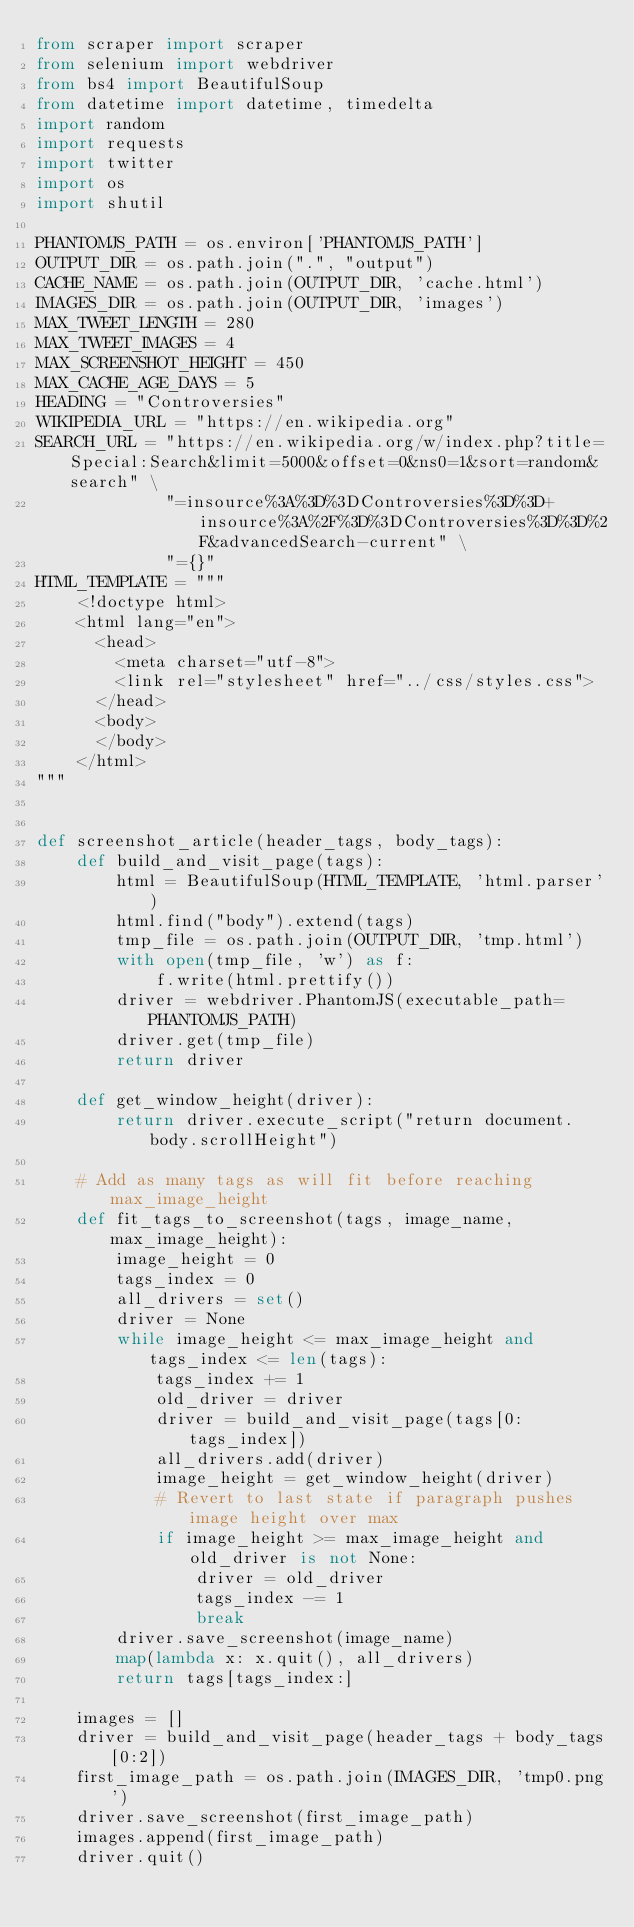Convert code to text. <code><loc_0><loc_0><loc_500><loc_500><_Python_>from scraper import scraper
from selenium import webdriver
from bs4 import BeautifulSoup
from datetime import datetime, timedelta
import random
import requests
import twitter
import os
import shutil

PHANTOMJS_PATH = os.environ['PHANTOMJS_PATH']
OUTPUT_DIR = os.path.join(".", "output")
CACHE_NAME = os.path.join(OUTPUT_DIR, 'cache.html')
IMAGES_DIR = os.path.join(OUTPUT_DIR, 'images')
MAX_TWEET_LENGTH = 280
MAX_TWEET_IMAGES = 4
MAX_SCREENSHOT_HEIGHT = 450
MAX_CACHE_AGE_DAYS = 5
HEADING = "Controversies"
WIKIPEDIA_URL = "https://en.wikipedia.org"
SEARCH_URL = "https://en.wikipedia.org/w/index.php?title=Special:Search&limit=5000&offset=0&ns0=1&sort=random&search" \
             "=insource%3A%3D%3DControversies%3D%3D+insource%3A%2F%3D%3DControversies%3D%3D%2F&advancedSearch-current" \
             "={}"
HTML_TEMPLATE = """
    <!doctype html>
    <html lang="en">
      <head>
        <meta charset="utf-8">
        <link rel="stylesheet" href="../css/styles.css">
      </head>
      <body>
      </body>
    </html>
"""


def screenshot_article(header_tags, body_tags):
    def build_and_visit_page(tags):
        html = BeautifulSoup(HTML_TEMPLATE, 'html.parser')
        html.find("body").extend(tags)
        tmp_file = os.path.join(OUTPUT_DIR, 'tmp.html')
        with open(tmp_file, 'w') as f:
            f.write(html.prettify())
        driver = webdriver.PhantomJS(executable_path=PHANTOMJS_PATH)
        driver.get(tmp_file)
        return driver

    def get_window_height(driver):
        return driver.execute_script("return document.body.scrollHeight")

    # Add as many tags as will fit before reaching max_image_height
    def fit_tags_to_screenshot(tags, image_name, max_image_height):
        image_height = 0
        tags_index = 0
        all_drivers = set()
        driver = None
        while image_height <= max_image_height and tags_index <= len(tags):
            tags_index += 1
            old_driver = driver
            driver = build_and_visit_page(tags[0:tags_index])
            all_drivers.add(driver)
            image_height = get_window_height(driver)
            # Revert to last state if paragraph pushes image height over max
            if image_height >= max_image_height and old_driver is not None:
                driver = old_driver
                tags_index -= 1
                break
        driver.save_screenshot(image_name)
        map(lambda x: x.quit(), all_drivers)
        return tags[tags_index:]

    images = []
    driver = build_and_visit_page(header_tags + body_tags[0:2])
    first_image_path = os.path.join(IMAGES_DIR, 'tmp0.png')
    driver.save_screenshot(first_image_path)
    images.append(first_image_path)
    driver.quit()
</code> 